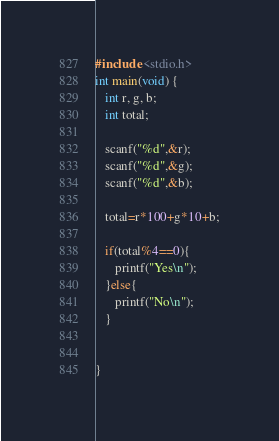<code> <loc_0><loc_0><loc_500><loc_500><_C_>#include <stdio.h>
int main(void) {
   int r, g, b;
   int total;
   
   scanf("%d",&r);
   scanf("%d",&g);
   scanf("%d",&b);
   
   total=r*100+g*10+b;
   
   if(total%4==0){
      printf("Yes\n");
   }else{
      printf("No\n");
   }
   
   
}</code> 